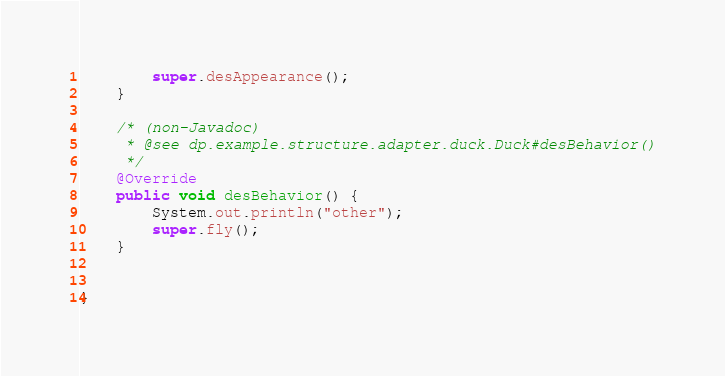Convert code to text. <code><loc_0><loc_0><loc_500><loc_500><_Java_>        super.desAppearance();
    }

    /* (non-Javadoc)
     * @see dp.example.structure.adapter.duck.Duck#desBehavior()
     */
    @Override
    public void desBehavior() {
        System.out.println("other");
        super.fly();
    }


}
</code> 